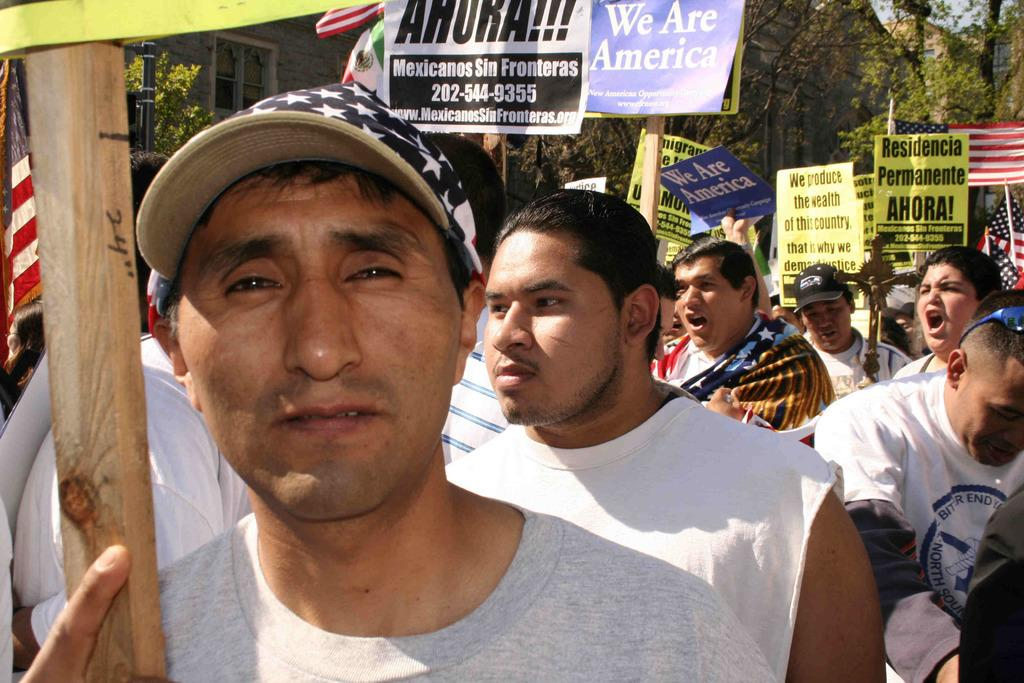How many people are present in the image? There are people in the image, but the exact number is not specified. What are some of the people holding in the image? Some people are holding objects in the image. What type of natural elements can be seen in the image? Trees are visible in the image. What type of man-made structures can be seen in the image? Houses and poles are present in the image. What type of signage is visible in the image? There are boards with text in the image. What type of decorative elements are present in the image? Flags are visible in the image. What type of farm animals can be seen grazing in the image? There is no mention of farm animals or a farm setting in the image. 